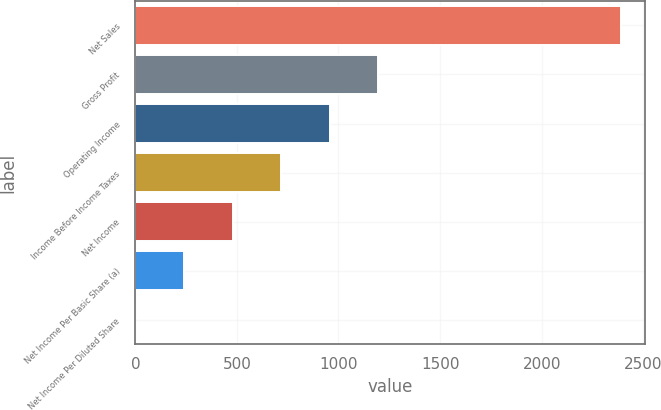Convert chart. <chart><loc_0><loc_0><loc_500><loc_500><bar_chart><fcel>Net Sales<fcel>Gross Profit<fcel>Operating Income<fcel>Income Before Income Taxes<fcel>Net Income<fcel>Net Income Per Basic Share (a)<fcel>Net Income Per Diluted Share<nl><fcel>2391<fcel>1195.78<fcel>956.73<fcel>717.68<fcel>478.63<fcel>239.58<fcel>0.53<nl></chart> 